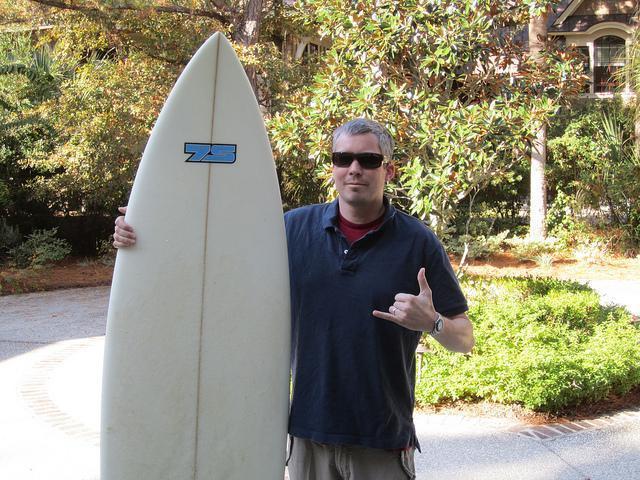How many dogs are outside?
Give a very brief answer. 0. 